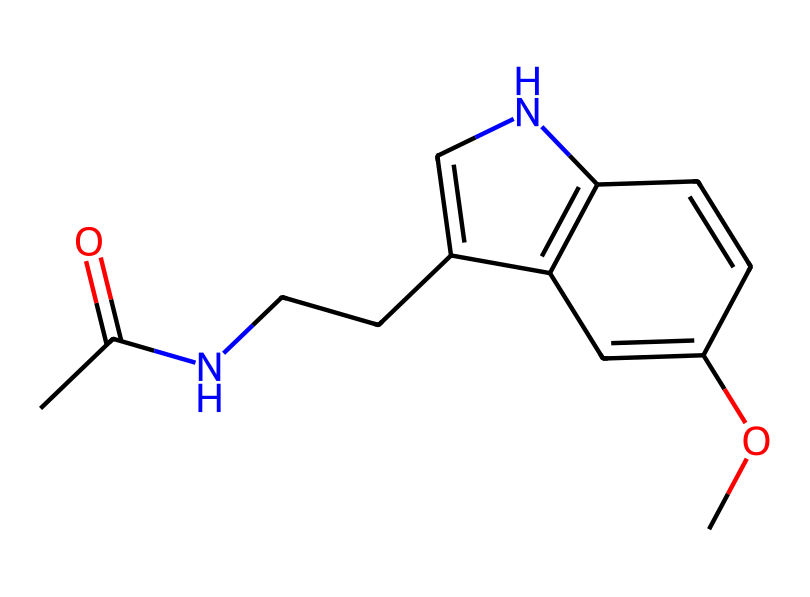What is the molecular formula of this antioxidant? To find the molecular formula, count the number of each type of atom represented in the structure. The given SMILES suggests there are 10 carbon (C) atoms, 13 hydrogen (H) atoms, 1 nitrogen (N) atom, and 3 oxygen (O) atoms. This results in the molecular formula C10H13N3O3.
Answer: C10H13N3O3 How many rings are present in this structure? Analyzing the structure in the SMILES, we can identify two distinct ring systems. The 'C' and 'N' atoms are interconnected in a cyclic manner, forming two rings in total.
Answer: 2 What type of chemical is this compound considered? This compound is recognized as an indole derivative based on its ring structure and substituents. Indole derivatives are known for their biological activity and antioxidant properties.
Answer: indole derivative How many double bonds can be found in this molecule? The structure includes a total of three double bonds, evident from the '=' symbols indicating connections between certain atoms. Counting these in the SMILES leads to a total of three double bonds.
Answer: 3 What functional groups are present in melatonin based on the structure? By examining the structure, we identify an acetyl group (-COCH3), amine group (-NH), and a methoxy group (-OCH3) as key functional groups in its molecular structure.
Answer: acetyl, amine, methoxy What role do the nitrogen atoms play in the antioxidant activity of this compound? Nitrogen atoms are crucial in forming active sites for electron donation, which is vital for the antioxidant properties of the compound, allowing it to neutralize free radicals effectively.
Answer: electron donor 